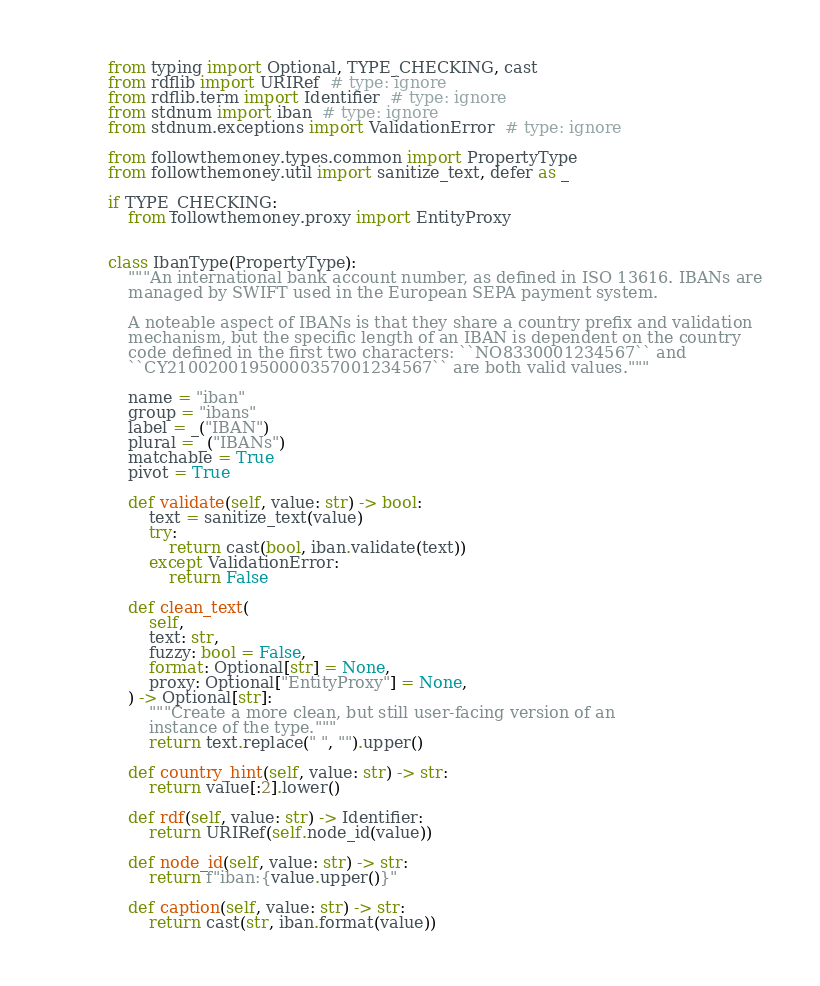<code> <loc_0><loc_0><loc_500><loc_500><_Python_>from typing import Optional, TYPE_CHECKING, cast
from rdflib import URIRef  # type: ignore
from rdflib.term import Identifier  # type: ignore
from stdnum import iban  # type: ignore
from stdnum.exceptions import ValidationError  # type: ignore

from followthemoney.types.common import PropertyType
from followthemoney.util import sanitize_text, defer as _

if TYPE_CHECKING:
    from followthemoney.proxy import EntityProxy


class IbanType(PropertyType):
    """An international bank account number, as defined in ISO 13616. IBANs are
    managed by SWIFT used in the European SEPA payment system.

    A noteable aspect of IBANs is that they share a country prefix and validation
    mechanism, but the specific length of an IBAN is dependent on the country
    code defined in the first two characters: ``NO8330001234567`` and
    ``CY21002001950000357001234567`` are both valid values."""

    name = "iban"
    group = "ibans"
    label = _("IBAN")
    plural = _("IBANs")
    matchable = True
    pivot = True

    def validate(self, value: str) -> bool:
        text = sanitize_text(value)
        try:
            return cast(bool, iban.validate(text))
        except ValidationError:
            return False

    def clean_text(
        self,
        text: str,
        fuzzy: bool = False,
        format: Optional[str] = None,
        proxy: Optional["EntityProxy"] = None,
    ) -> Optional[str]:
        """Create a more clean, but still user-facing version of an
        instance of the type."""
        return text.replace(" ", "").upper()

    def country_hint(self, value: str) -> str:
        return value[:2].lower()

    def rdf(self, value: str) -> Identifier:
        return URIRef(self.node_id(value))

    def node_id(self, value: str) -> str:
        return f"iban:{value.upper()}"

    def caption(self, value: str) -> str:
        return cast(str, iban.format(value))
</code> 